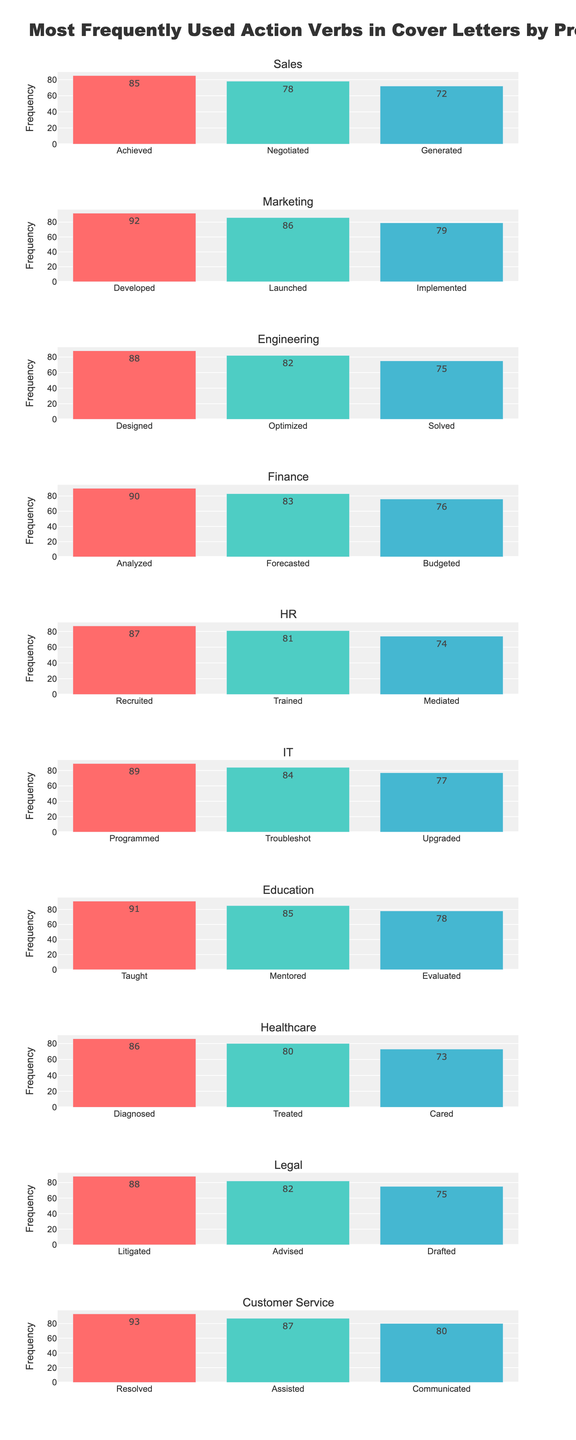Which profession uses the action verb "Negotiated" the most frequently? Look at the bar chart for the word "Negotiated" and identify the profession with the highest bar.
Answer: Sales What is the total frequency of action verbs used by the HR profession? Sum the frequencies of "Recruited," "Trained," and "Mediated" for the HR profession: 87 + 81 + 74 = 242.
Answer: 242 Which action verb is used most frequently by the Customer Service profession? Identify the tallest bar under the Customer Service profession.
Answer: Resolved How does the frequency of "Designed" in Engineering compare to "Diagnosed" in Healthcare? Compare the heights of the bars for "Designed" in Engineering (88) and "Diagnosed" in Healthcare (86). "Designed" is used more frequently.
Answer: Designed What is the least frequently used action verb in the Finance and IT professions? Identify the shortest bars in the Finance and IT categories. For Finance, it's "Budgeted" with 76. For IT, it's "Upgraded" with 77.
Answer: Budgeted (Finance), Upgraded (IT) What is the average frequency of the action verbs used in the Engineering profession? Sum the frequencies of "Designed," "Optimized," and "Solved" (88 + 82 + 75 = 245), then divide by 3. The average is 245/3 ≈ 81.67.
Answer: 81.67 Is "Programmed" or "Forecasted" used more frequently, and by how much? Compare the frequencies of "Programmed" in IT (89) and "Forecasted" in Finance (83). Calculate the difference: 89 - 83 = 6.
Answer: Programmed by 6 Which action verbs have a frequency greater than 80 in the Marketing profession? Identify bars in the Marketing category with a height greater than 80: "Developed" (92), "Launched" (86), and "Implemented" (79, which is not greater than 80).
Answer: Developed, Launched What is the difference in frequency between "Generated" in Sales and "Upgraded" in IT? Subtract the frequency of "Upgraded" in IT (77) from "Generated" in Sales (72). 72 - 77 = -5.
Answer: -5 How many action verbs have a frequency exceeding 85 across all professions? Identify bars with frequencies above 85: "Developed" (92), "Launched" (86), "Designed" (88), "Taught" (91), "Resolved" (93), "Analyzed" (90), "Programmed" (89), "Recruited" (87), "Mentored" (85), "Achieved" (85) which sums up to 9 verbs..
Answer: 9 